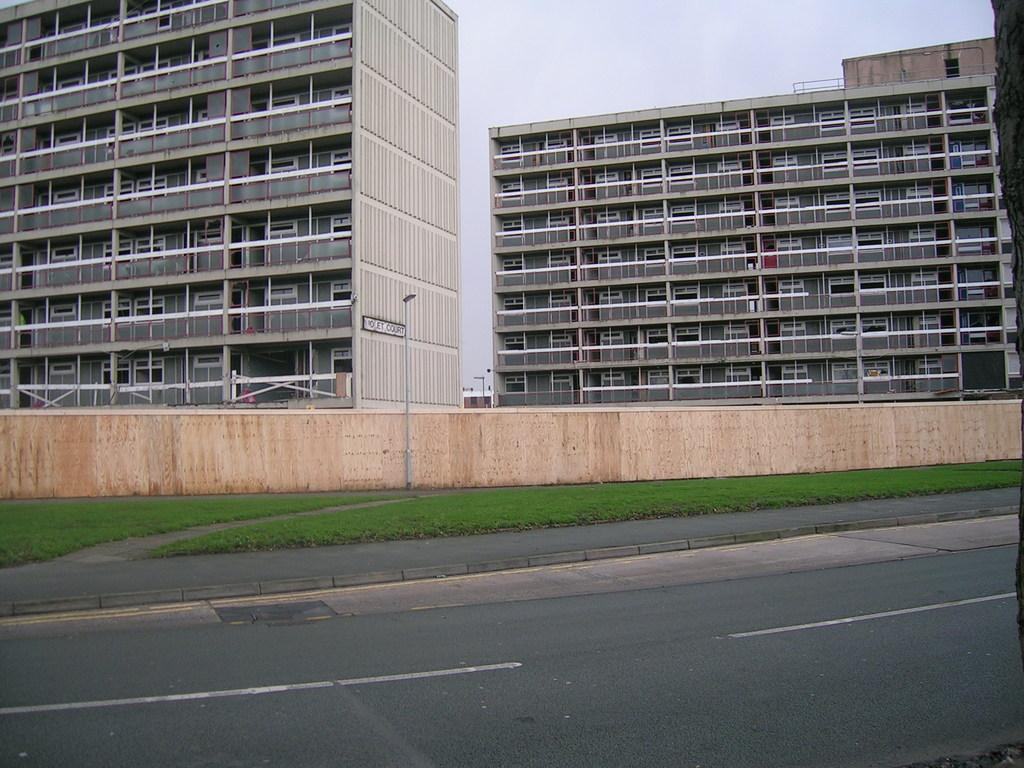What structures can be seen in the image? There are buildings in the image. What is located beside the road in the image? There is a wall beside the road in the image. What is visible at the top of the image? The sky is visible at the top of the image. How many pigs are sitting on the branch in the image? There are no pigs or branches present in the image. What color is the horse in the image? There is no horse present in the image. 